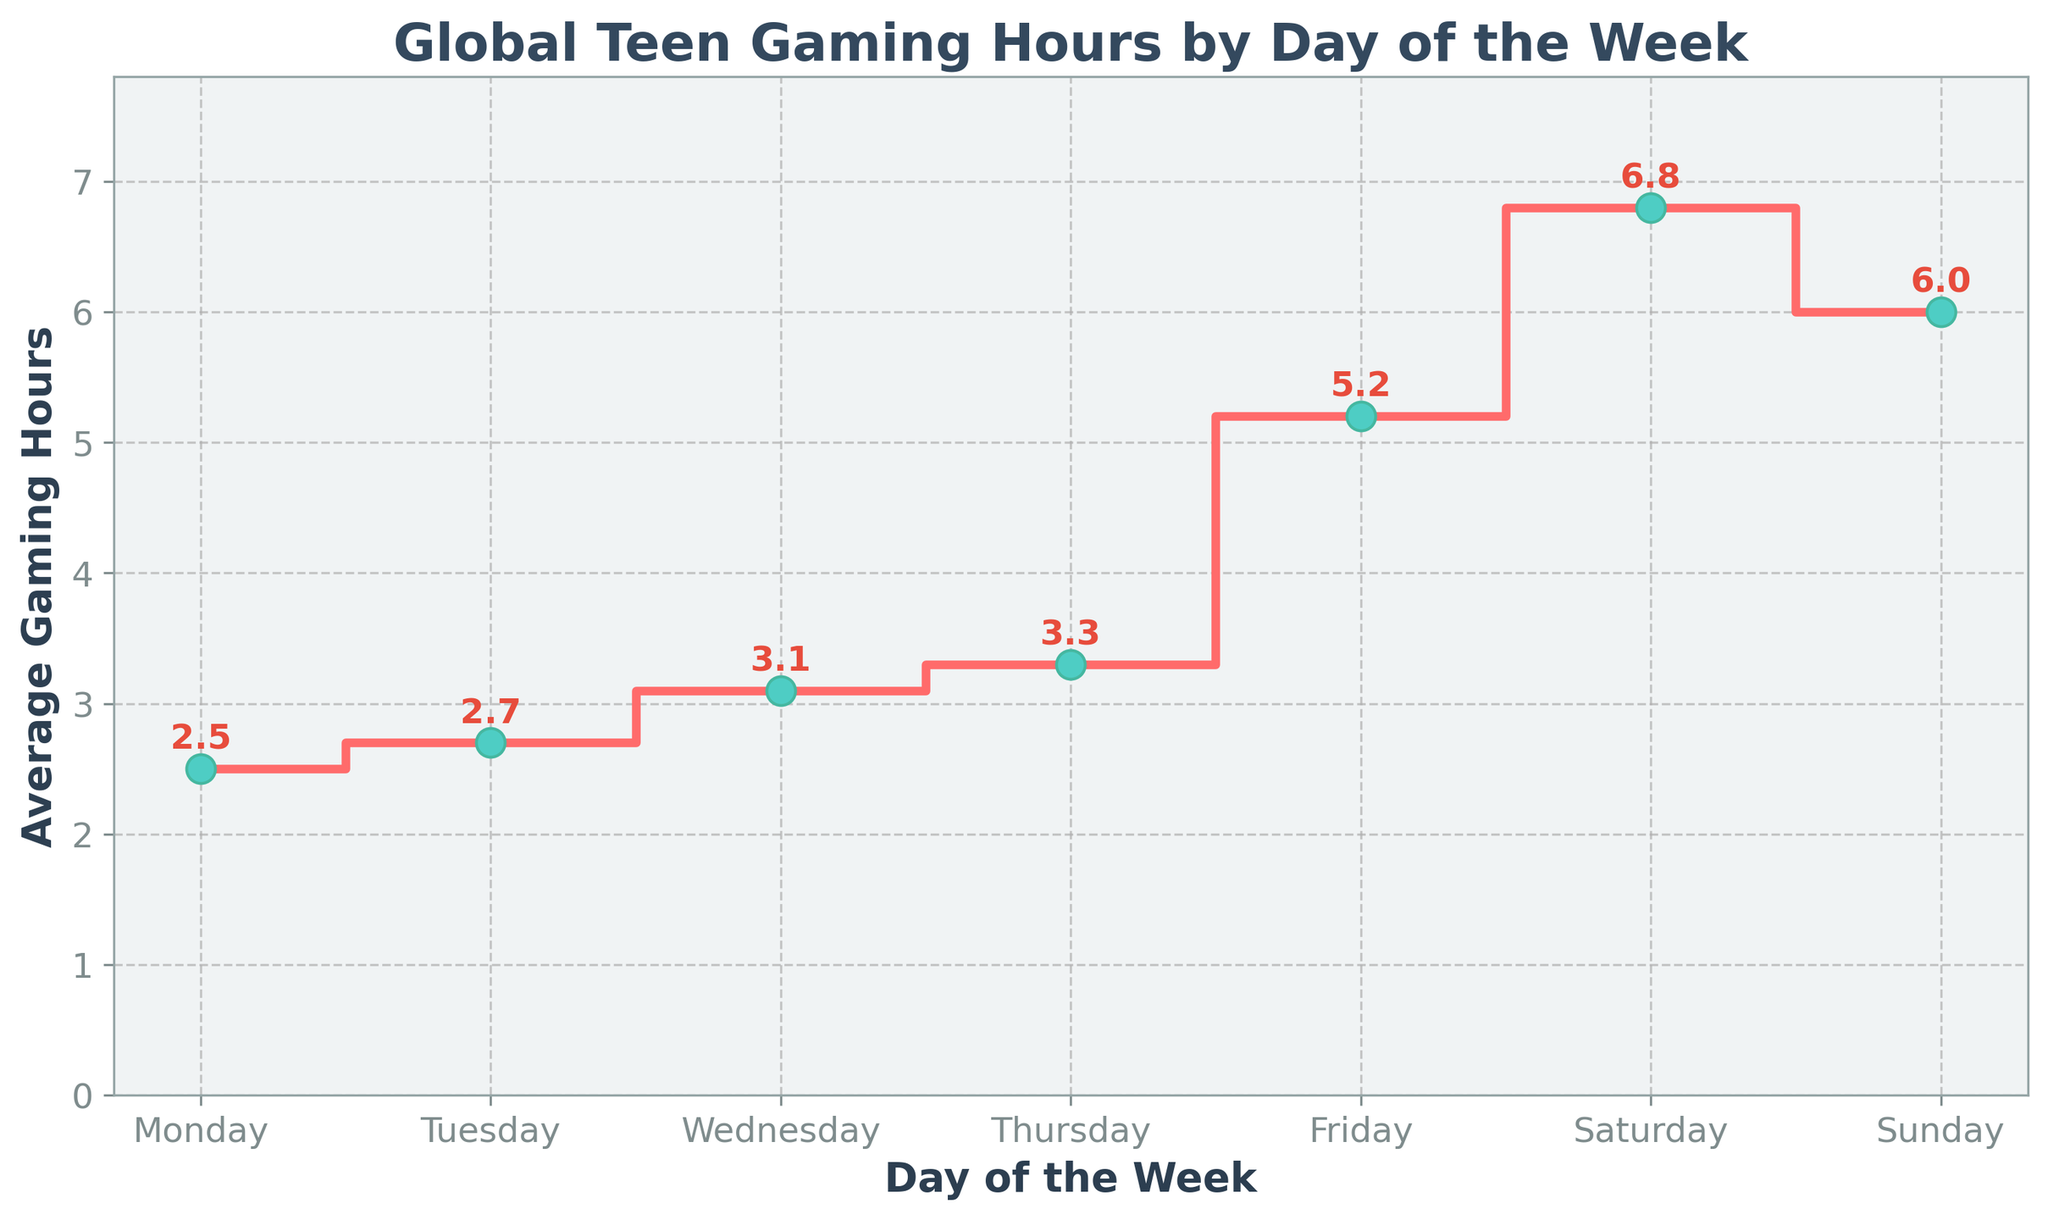what is the title of the plot? The title of the plot is usually located at the top of the figure and is displayed in larger bold text. By looking at the rendered figure, you can read the title directly from the top.
Answer: Global Teen Gaming Hours by Day of the Week What is the day with the highest average gaming hours? To determine this, look at the y-values associated with each day on the x-axis. The day with the value closest to the top of the plot has the highest average gaming hours.
Answer: Saturday On which day is the increase in average gaming hours the largest from one day to the next? To find the day with the largest increase, examine the vertical steps between points on the plot. Calculate the differences between consecutive days to see which one is the largest.
Answer: Thursday to Friday How many data points are there in the plot? The number of data points corresponds to the number of days displayed on the x-axis. Count the days on the x-axis to determine this.
Answer: 7 What is the average value of the gaming hours over the whole week? Sum the average gaming hours for each day, then divide by the number of days (7): (2.5 + 2.7 + 3.1 + 3.3 + 5.2 + 6.8 + 6.0) / 7 = 4.22857
Answer: 4.23 What's the total gaming hours from Monday to Wednesday? To find the total for Monday to Wednesday, sum the average gaming hours for these three days: 2.5 + 2.7 + 3.1 = 8.3
Answer: 8.3 Is the average gaming time on weekends higher than on weekdays? Compare the sum of the average gaming hours on Saturday and Sunday to the sum of the hours from Monday to Friday. If the total for the weekend is higher, then yes, it is higher. Weekends: 6.8 + 6.0 = 12.8; Weekdays: 2.5 + 2.7 + 3.1 + 3.3 + 5.2 = 16.8. Compare the sums: 12.8 < 16.8
Answer: No By how many hours does the average gaming time increase from Monday to Sunday? Calculate the difference in gaming hours from Monday to Sunday by subtracting Monday's value from Sunday's value: 6.0 - 2.5 = 3.5
Answer: 3.5 